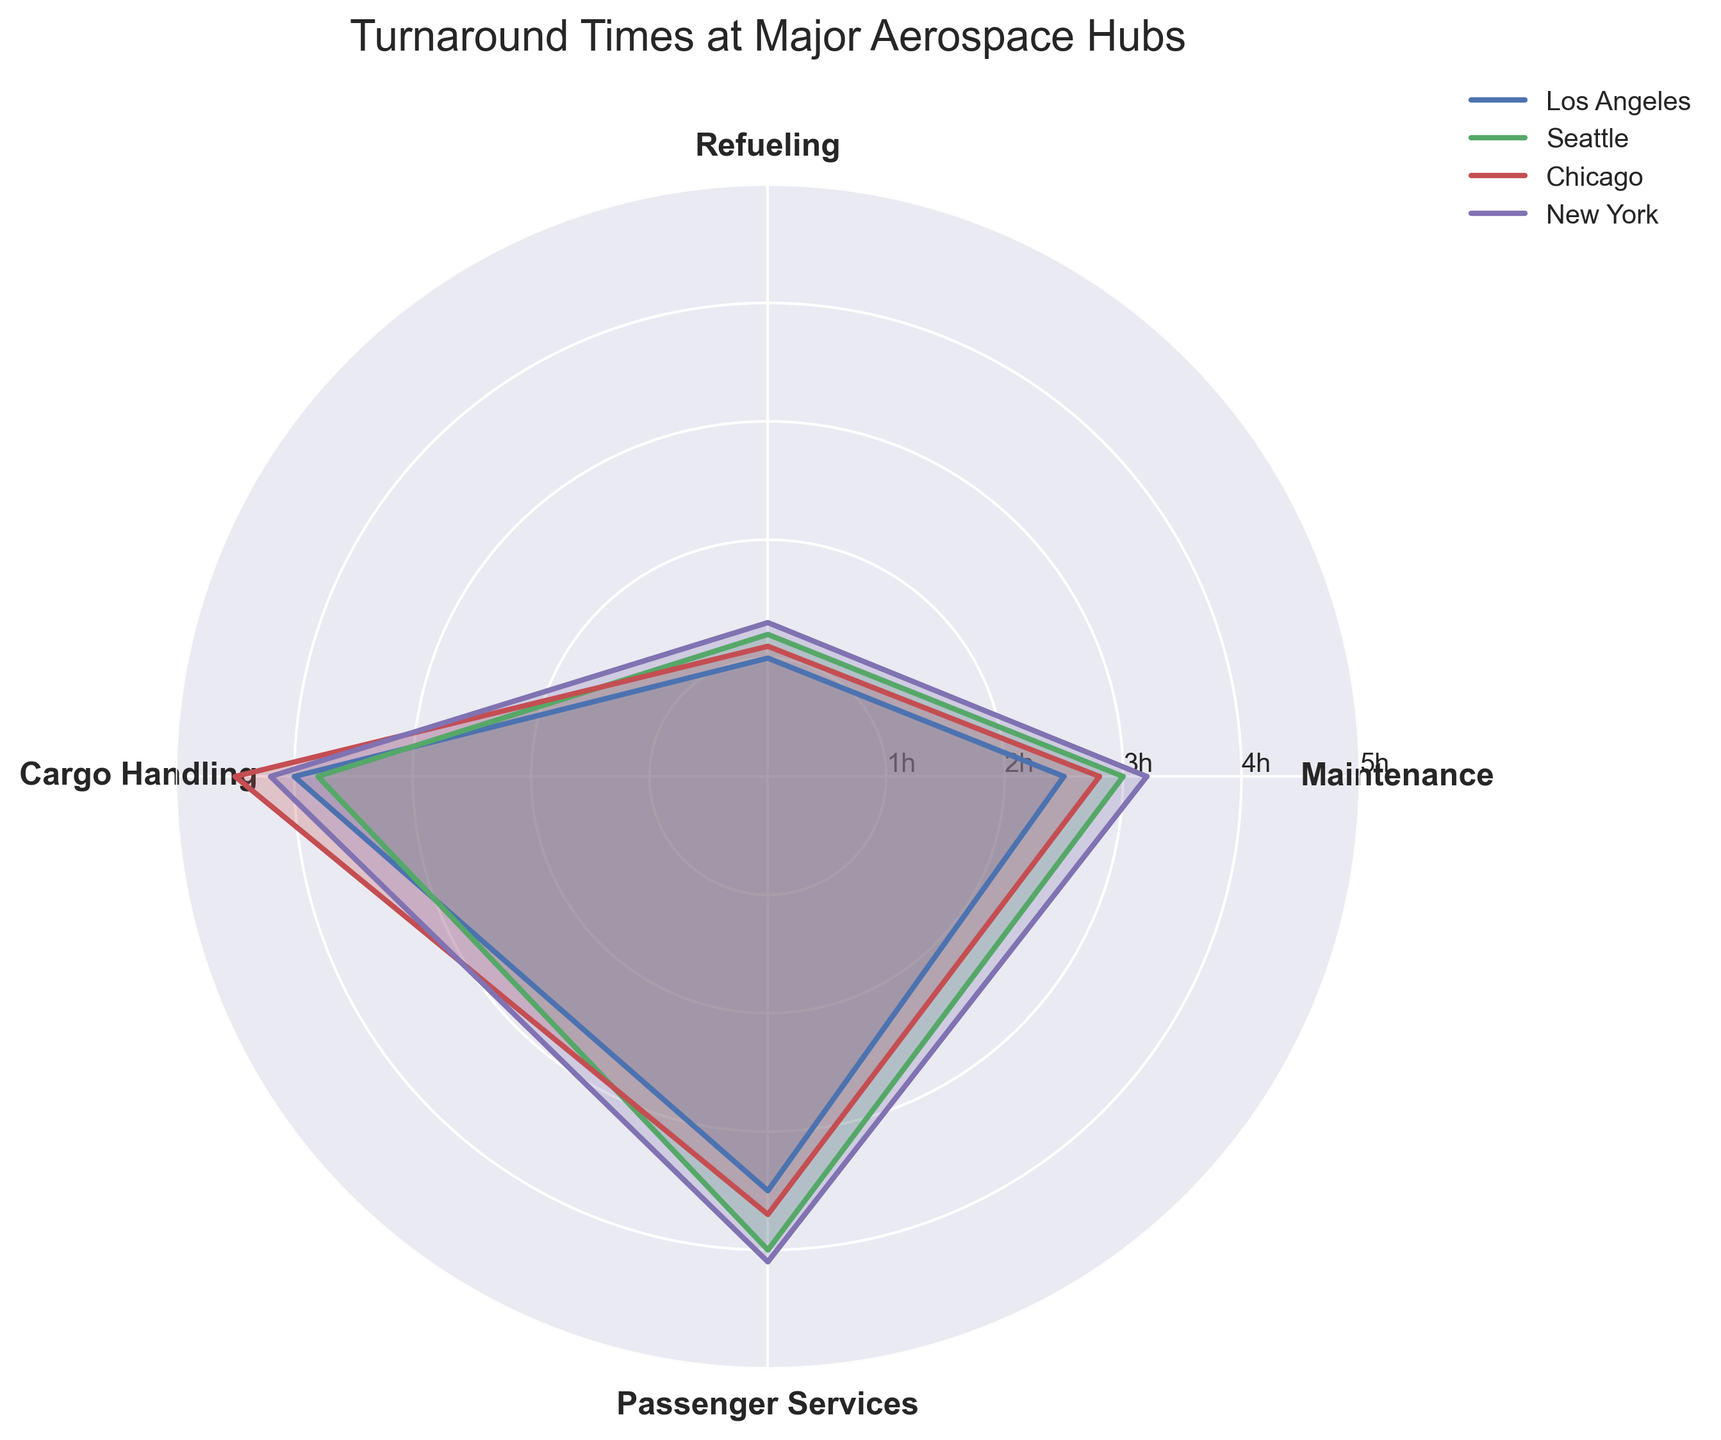What is the title of the radar chart? The title is presented at the top of the chart. It summarizes the main focus of the visualization.
Answer: Turnaround Times at Major Aerospace Hubs Which category has the highest turnaround time for New York? Identify the New York hub on the chart. Follow the plot line for New York, and identify the category where the value is highest.
Answer: Passenger Services What is the average turnaround time for Maintenance across all hubs? Sum the Maintenance turnaround times for all hubs and divide by the number of hubs: (2.5 + 3.0 + 2.8 + 3.2) / 4.
Answer: 2.875 hours Which hub has the shortest turnaround time for Refueling? Compare the Refueling values for all hubs and identify the smallest value.
Answer: Los Angeles How does Seattle's turnaround time for Cargo Handling compare to Chicago's? Locate the Cargo Handling values for Seattle and Chicago, then compare them. Seattle has 3.8 hours and Chicago has 4.5 hours.
Answer: Seattle's Cargo Handling time is shorter Which hub shows the most balanced turnaround times across all categories? Assess the turnarounds for each hub, focusing on how close the values are to each other in the radar chart. Seattle's values (3.0, 1.2, 3.8, 4.0) are relatively close to each other compared to others.
Answer: Seattle What is the difference between the highest and lowest turnaround time for Los Angeles? Identify the highest and lowest values for Los Angeles: Highest (Cargo Handling, 4.0), Lowest (Refueling, 1.0). Difference = 4.0 - 1.0.
Answer: 3.0 hours Rank the hubs from fastest to slowest overall based on their Passenger Services times. Analyze the Passenger Services values for all hubs and rank them. New York (4.1), Seattle (4.0), Chicago (3.7), Los Angeles (3.5).
Answer: Los Angeles < Chicago < Seattle < New York How many hubs have a Maintenance turnaround time of 3 hours or more? Identify the Maintenance values that are 3 or more: Seattle (3.0), New York (3.2). Count them.
Answer: 2 hubs What specific operation values make Chicago's turnaround time particularly higher or lower in any category? Review Chicago's values (Maintenance: 2.8, Refueling: 1.1, Cargo Handling: 4.5, Passenger Services: 3.7). The Cargo Handling value of 4.5 is particularly higher than other categories for Chicago.
Answer: Cargo Handling (4.5) 